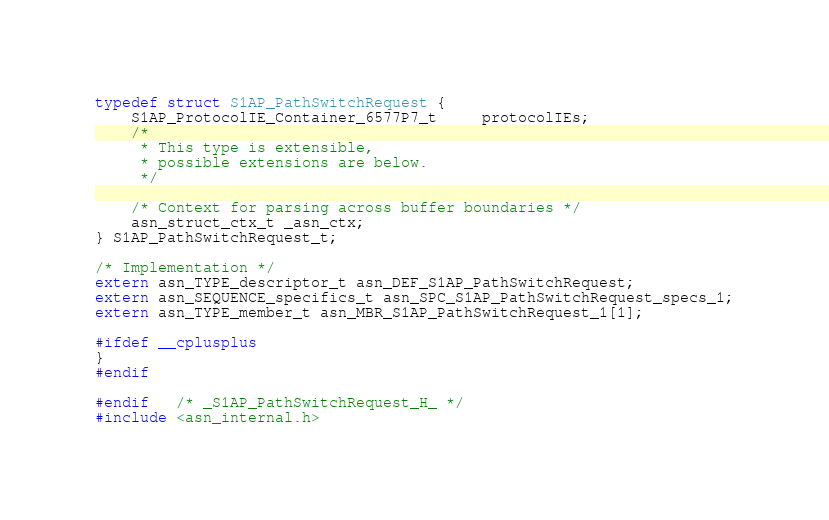<code> <loc_0><loc_0><loc_500><loc_500><_C_>typedef struct S1AP_PathSwitchRequest {
	S1AP_ProtocolIE_Container_6577P7_t	 protocolIEs;
	/*
	 * This type is extensible,
	 * possible extensions are below.
	 */
	
	/* Context for parsing across buffer boundaries */
	asn_struct_ctx_t _asn_ctx;
} S1AP_PathSwitchRequest_t;

/* Implementation */
extern asn_TYPE_descriptor_t asn_DEF_S1AP_PathSwitchRequest;
extern asn_SEQUENCE_specifics_t asn_SPC_S1AP_PathSwitchRequest_specs_1;
extern asn_TYPE_member_t asn_MBR_S1AP_PathSwitchRequest_1[1];

#ifdef __cplusplus
}
#endif

#endif	/* _S1AP_PathSwitchRequest_H_ */
#include <asn_internal.h>
</code> 